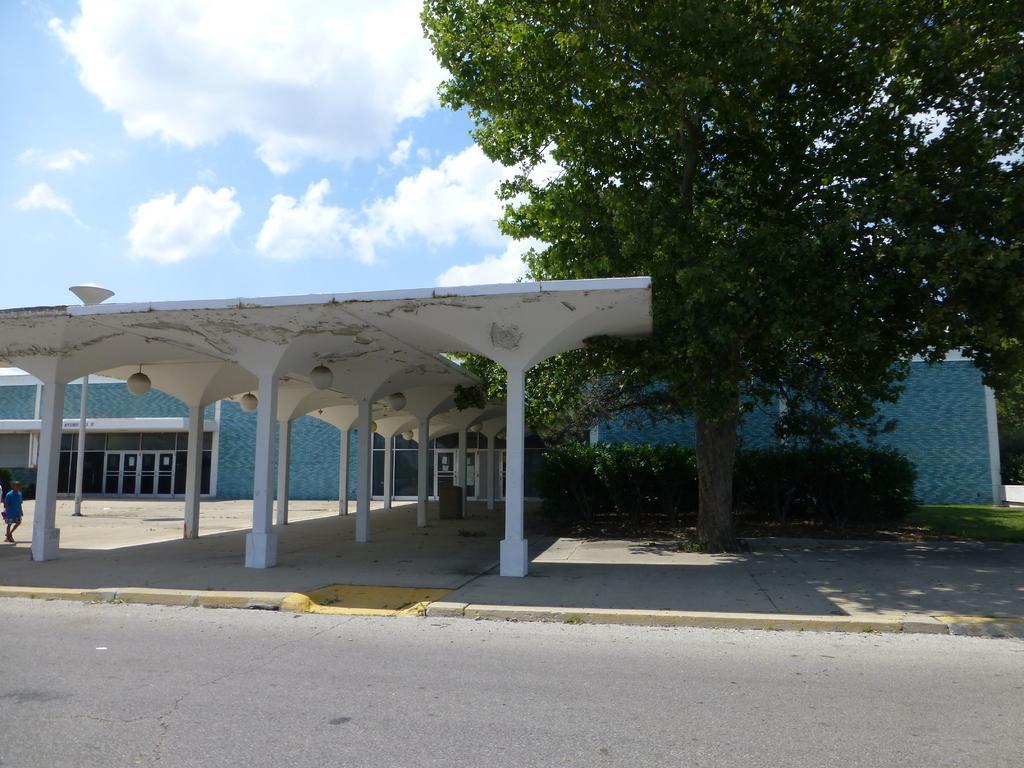Can you describe this image briefly? In this image we can see there is a person walking on the ground. At the back there is a building, in front of the building there is a shed with pillars and lights. At the side there are trees, grass and the sky. 